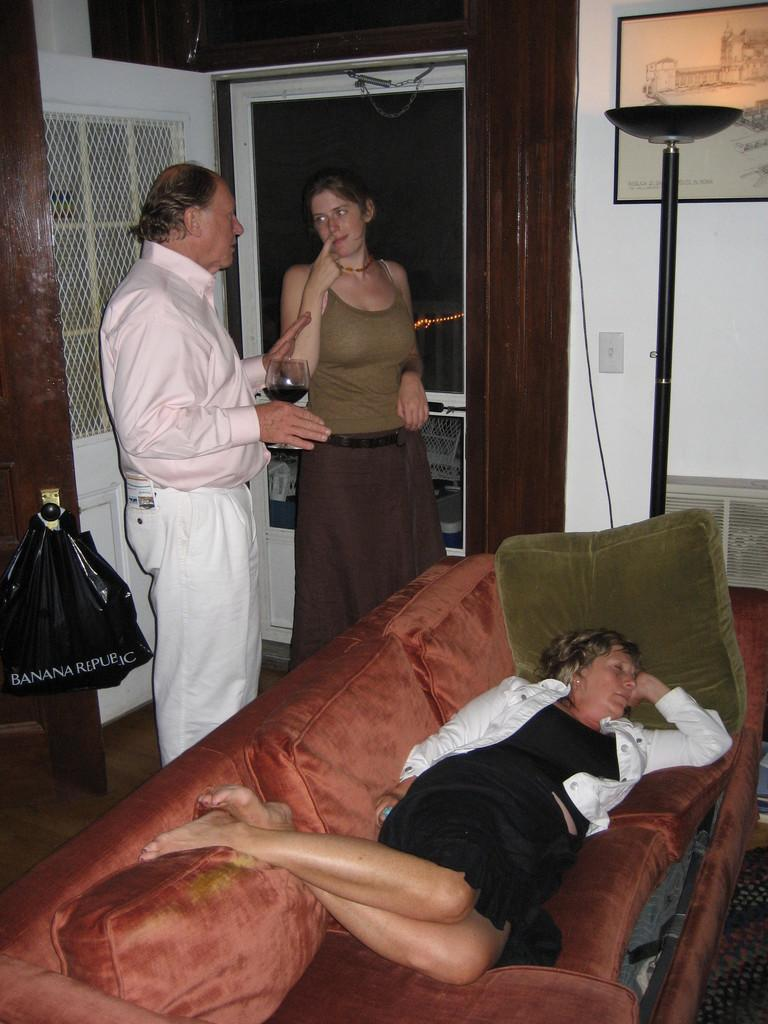What is the color of the wall in the image? The wall in the image is white. What can be seen hanging on the wall? There is a photo frame in the image. How many people are present in the image? There are three people in the image. What is the woman wearing in the image? The woman is wearing a black color dress. What is the woman doing in the image? The woman is sleeping on the sofa. What type of advertisement is being displayed on the sofa? There is no advertisement present in the image; it is a woman sleeping on the sofa. How can the sofa be expanded to accommodate more people? The image does not show any mechanism for expanding the sofa, and there is no mention of such a feature in the provided facts. 